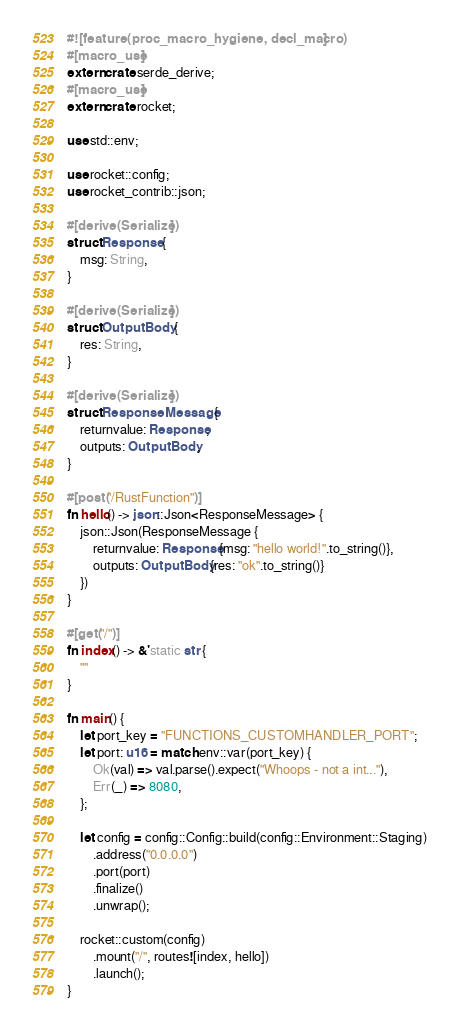Convert code to text. <code><loc_0><loc_0><loc_500><loc_500><_Rust_>#![feature(proc_macro_hygiene, decl_macro)]
#[macro_use]
extern crate serde_derive;
#[macro_use]
extern crate rocket;

use std::env;

use rocket::config;
use rocket_contrib::json;

#[derive(Serialize)]
struct Response {
    msg: String,
}

#[derive(Serialize)]
struct OutputBody {
    res: String,
}

#[derive(Serialize)]
struct ResponseMessage {
    returnvalue: Response,
    outputs: OutputBody,
}

#[post("/RustFunction")]
fn hello() -> json::Json<ResponseMessage> {
    json::Json(ResponseMessage {
        returnvalue: Response{msg: "hello world!".to_string()},
        outputs: OutputBody{res: "ok".to_string()}
    })
}

#[get("/")]
fn index() -> &'static str {
    ""
}

fn main() {
    let port_key = "FUNCTIONS_CUSTOMHANDLER_PORT";
    let port: u16 = match env::var(port_key) {
        Ok(val) => val.parse().expect("Whoops - not a int..."),
        Err(_) => 8080,
    };

    let config = config::Config::build(config::Environment::Staging)
        .address("0.0.0.0")
        .port(port)
        .finalize()
        .unwrap();

    rocket::custom(config)
        .mount("/", routes![index, hello])
        .launch();
}
</code> 